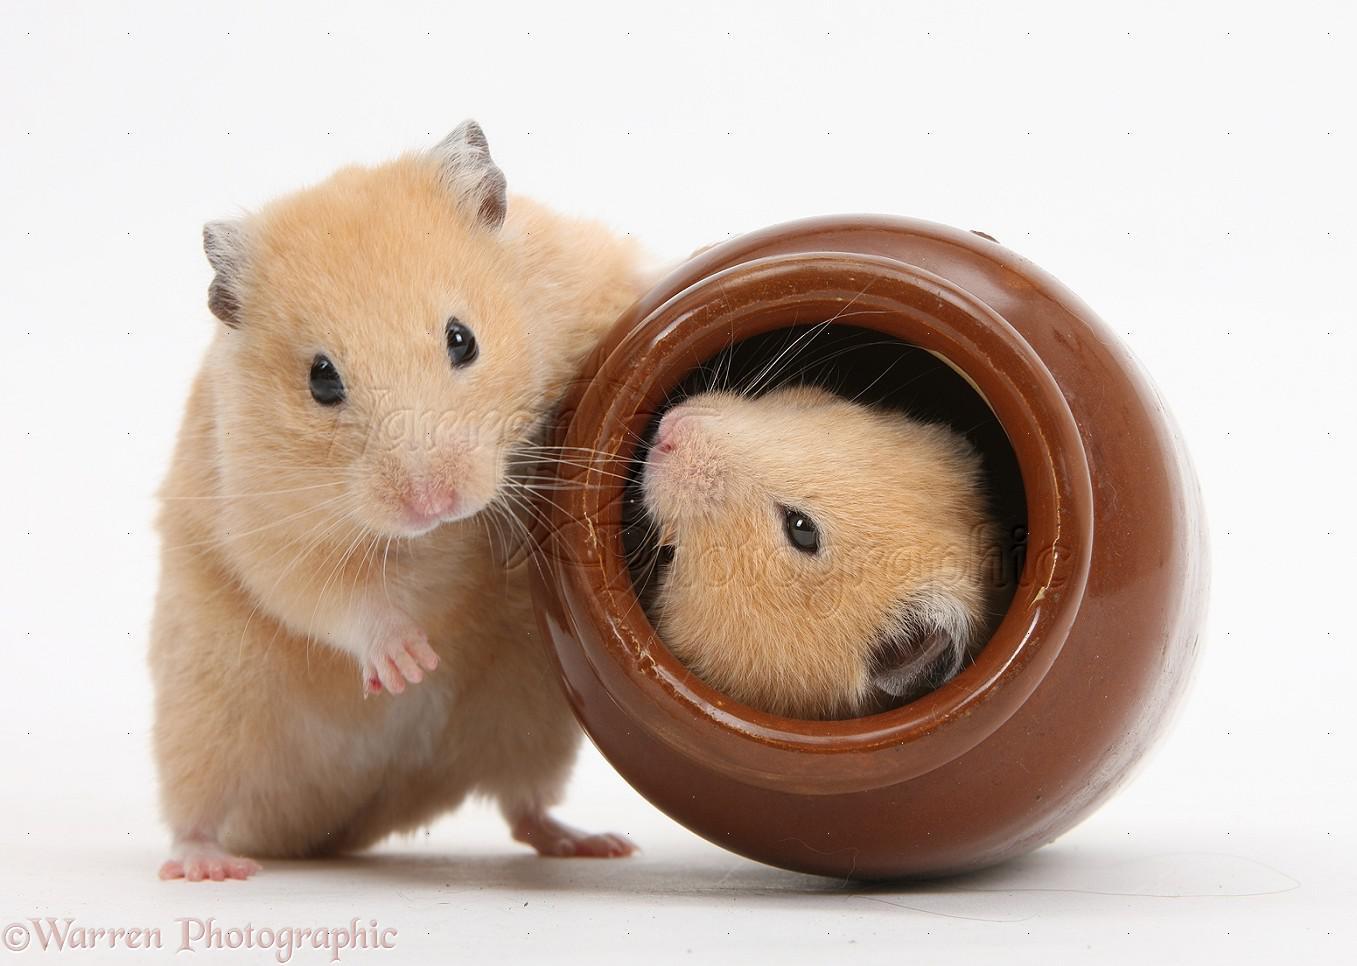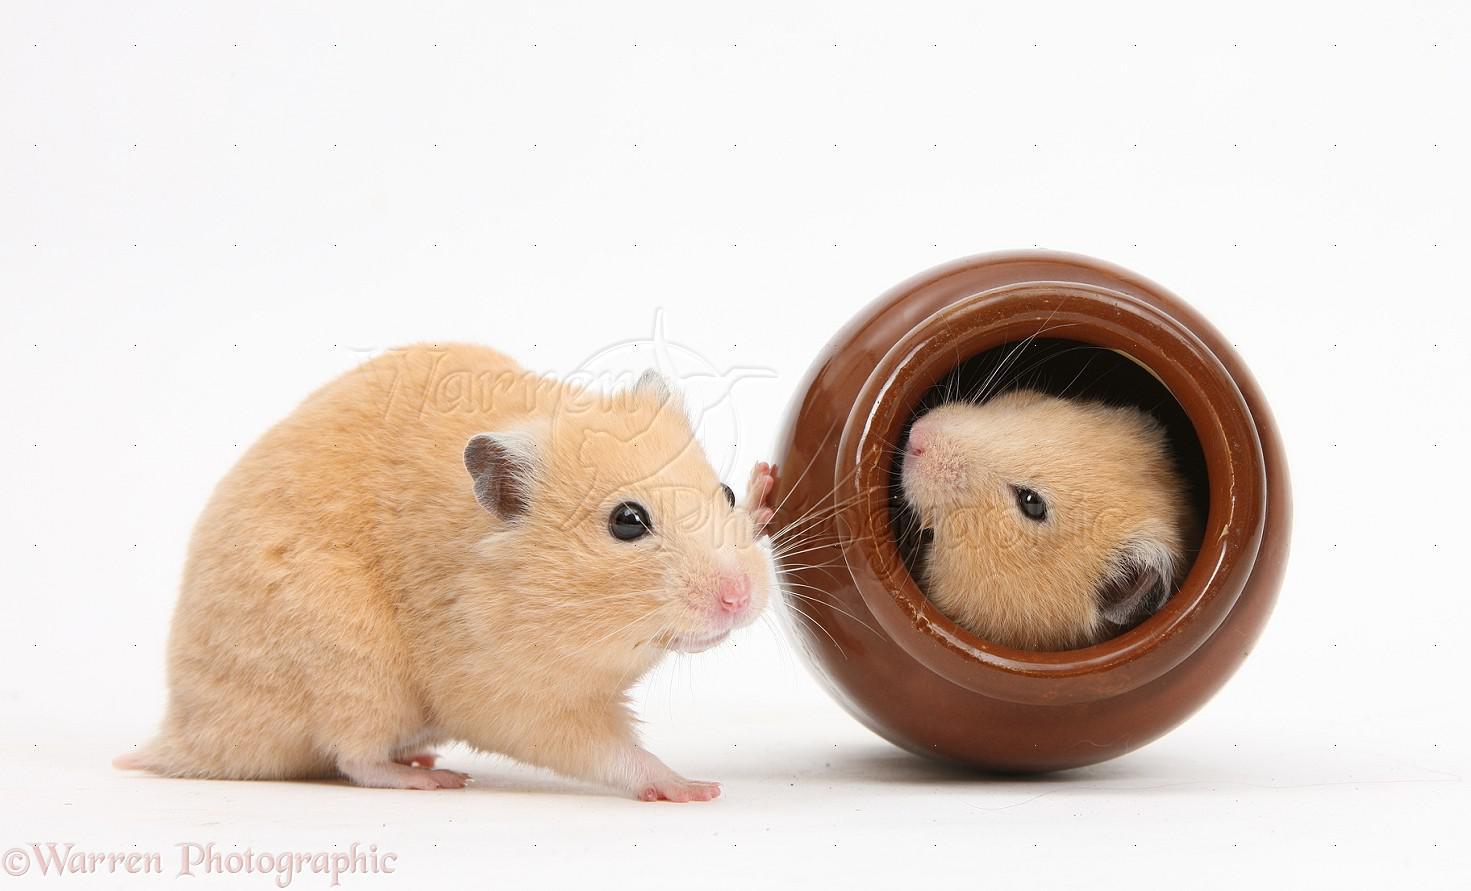The first image is the image on the left, the second image is the image on the right. For the images shown, is this caption "An edible item is to the left of a small rodent in one image." true? Answer yes or no. No. The first image is the image on the left, the second image is the image on the right. Analyze the images presented: Is the assertion "Food sits on the surface in front of a rodent in one of the images." valid? Answer yes or no. No. 